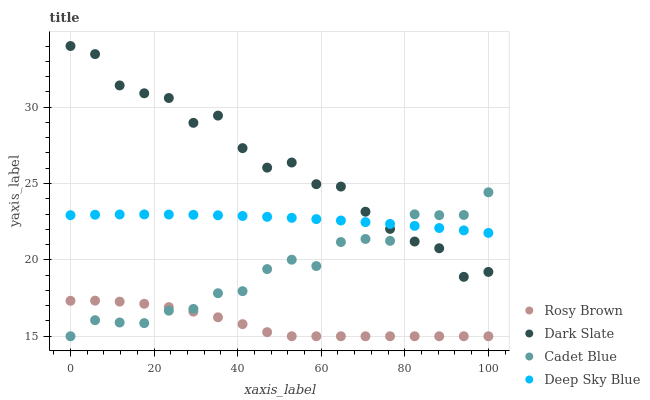Does Rosy Brown have the minimum area under the curve?
Answer yes or no. Yes. Does Dark Slate have the maximum area under the curve?
Answer yes or no. Yes. Does Dark Slate have the minimum area under the curve?
Answer yes or no. No. Does Rosy Brown have the maximum area under the curve?
Answer yes or no. No. Is Deep Sky Blue the smoothest?
Answer yes or no. Yes. Is Dark Slate the roughest?
Answer yes or no. Yes. Is Rosy Brown the smoothest?
Answer yes or no. No. Is Rosy Brown the roughest?
Answer yes or no. No. Does Cadet Blue have the lowest value?
Answer yes or no. Yes. Does Dark Slate have the lowest value?
Answer yes or no. No. Does Dark Slate have the highest value?
Answer yes or no. Yes. Does Rosy Brown have the highest value?
Answer yes or no. No. Is Rosy Brown less than Deep Sky Blue?
Answer yes or no. Yes. Is Dark Slate greater than Rosy Brown?
Answer yes or no. Yes. Does Dark Slate intersect Cadet Blue?
Answer yes or no. Yes. Is Dark Slate less than Cadet Blue?
Answer yes or no. No. Is Dark Slate greater than Cadet Blue?
Answer yes or no. No. Does Rosy Brown intersect Deep Sky Blue?
Answer yes or no. No. 